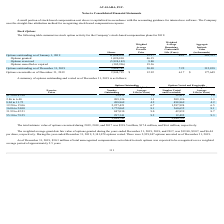From Avalara's financial document, What are the total respective values of options exercised during 2019, 2018 and 2017 respectively? The document contains multiple relevant values: $318.5 million, $17.4 million, $6.6 million. From the document: "ed during 2019, 2018, and 2017 was $318.5 million, $17.4 million, and $6.6 million, respectively. options exercised during 2019, 2018, and 2017 was $3..." Also, What are the weighted average grant date fair value of options granted during the years ended December 31, 2019, 2018, and 2017 respectively? The document contains multiple relevant values: $19.80, $9.07, $6.44. From the document: "r 31, 2019, 2018, and 2017, was $19.80, $9.07, and $6.44 years ended December 31, 2019, 2018, and 2017, was $19.80, $9.07, and $6.44 ded December 31, ..." Also, As of December 31, 2019, what is the value of the total unrecognized compensation cost related to stock options was expected to be recognized? According to the financial document, $30.3 million. The relevant text states: "As of December 31, 2019, $30.3 million of total unrecognized compensation cost related to stock options was expected to be recognized over..." Also, can you calculate: What is the number of outstanding options whose exercise price are between $1.50 to $6.40? Based on the calculation: 32,913 + 209,126 , the result is 242039. This is based on the information: "$1.50 to $1.90 32,913 1.4 32,913 1.4 2.86 to 6.40 209,126 3.3 209,126 3.3..." The key data points involved are: 209,126, 32,913. Also, can you calculate: What would be the number of outstanding options whose exercise price are between $8.04 to $15.06? Based on the calculation: 498,869 + 2,227,421 , the result is 2726290. This is based on the information: "12.20 to 15.06 2,227,421 6.7 1,587,924 6.5 8.04 to 11.72 498,869 4.2 498,869 4.2..." The key data points involved are: 2,227,421, 498,869. Also, can you calculate: What is the number of outstanding options with an exercise price of between 12.20 to 15.06 as a percentage of the total number of outstanding options? Based on the calculation: 2,227,421/5,884,742 , the result is 37.85 (percentage). This is based on the information: "12.20 to 15.06 2,227,421 6.7 1,587,924 6.5 5,884,742 2,944,795..." The key data points involved are: 2,227,421, 5,884,742. 